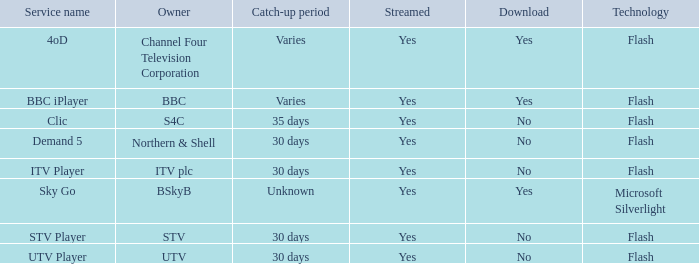What is available for download throughout the distinct catch-up periods? Yes, Yes. 